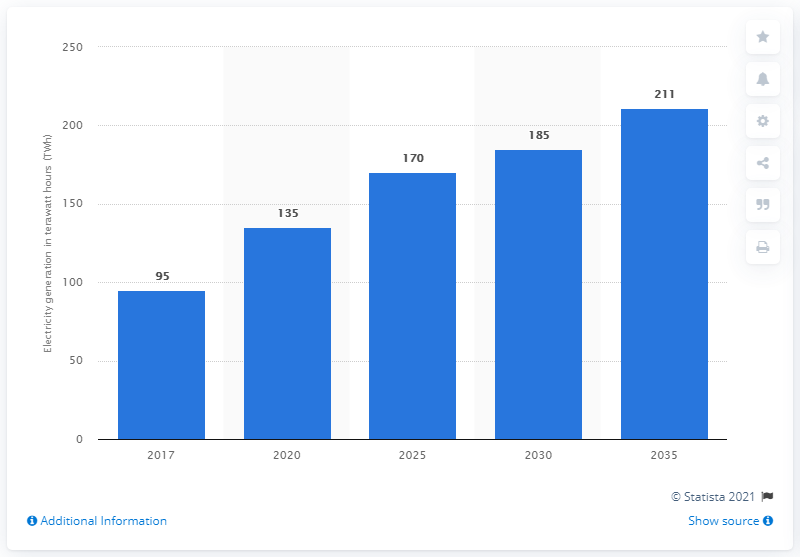Mention a couple of crucial points in this snapshot. In 2035, renewable energy was expected to reach a total of 211 terawatt hours. 